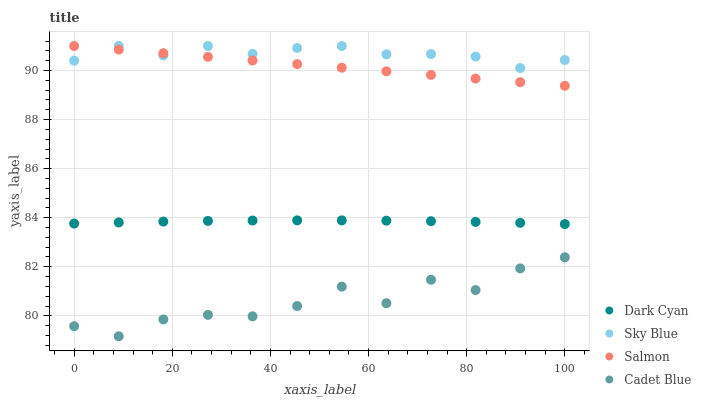Does Cadet Blue have the minimum area under the curve?
Answer yes or no. Yes. Does Sky Blue have the maximum area under the curve?
Answer yes or no. Yes. Does Sky Blue have the minimum area under the curve?
Answer yes or no. No. Does Cadet Blue have the maximum area under the curve?
Answer yes or no. No. Is Salmon the smoothest?
Answer yes or no. Yes. Is Cadet Blue the roughest?
Answer yes or no. Yes. Is Sky Blue the smoothest?
Answer yes or no. No. Is Sky Blue the roughest?
Answer yes or no. No. Does Cadet Blue have the lowest value?
Answer yes or no. Yes. Does Sky Blue have the lowest value?
Answer yes or no. No. Does Salmon have the highest value?
Answer yes or no. Yes. Does Cadet Blue have the highest value?
Answer yes or no. No. Is Dark Cyan less than Sky Blue?
Answer yes or no. Yes. Is Salmon greater than Dark Cyan?
Answer yes or no. Yes. Does Sky Blue intersect Salmon?
Answer yes or no. Yes. Is Sky Blue less than Salmon?
Answer yes or no. No. Is Sky Blue greater than Salmon?
Answer yes or no. No. Does Dark Cyan intersect Sky Blue?
Answer yes or no. No. 